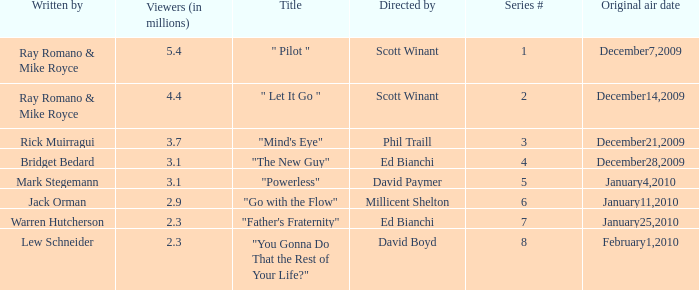What is the title of the episode written by Jack Orman? "Go with the Flow". 